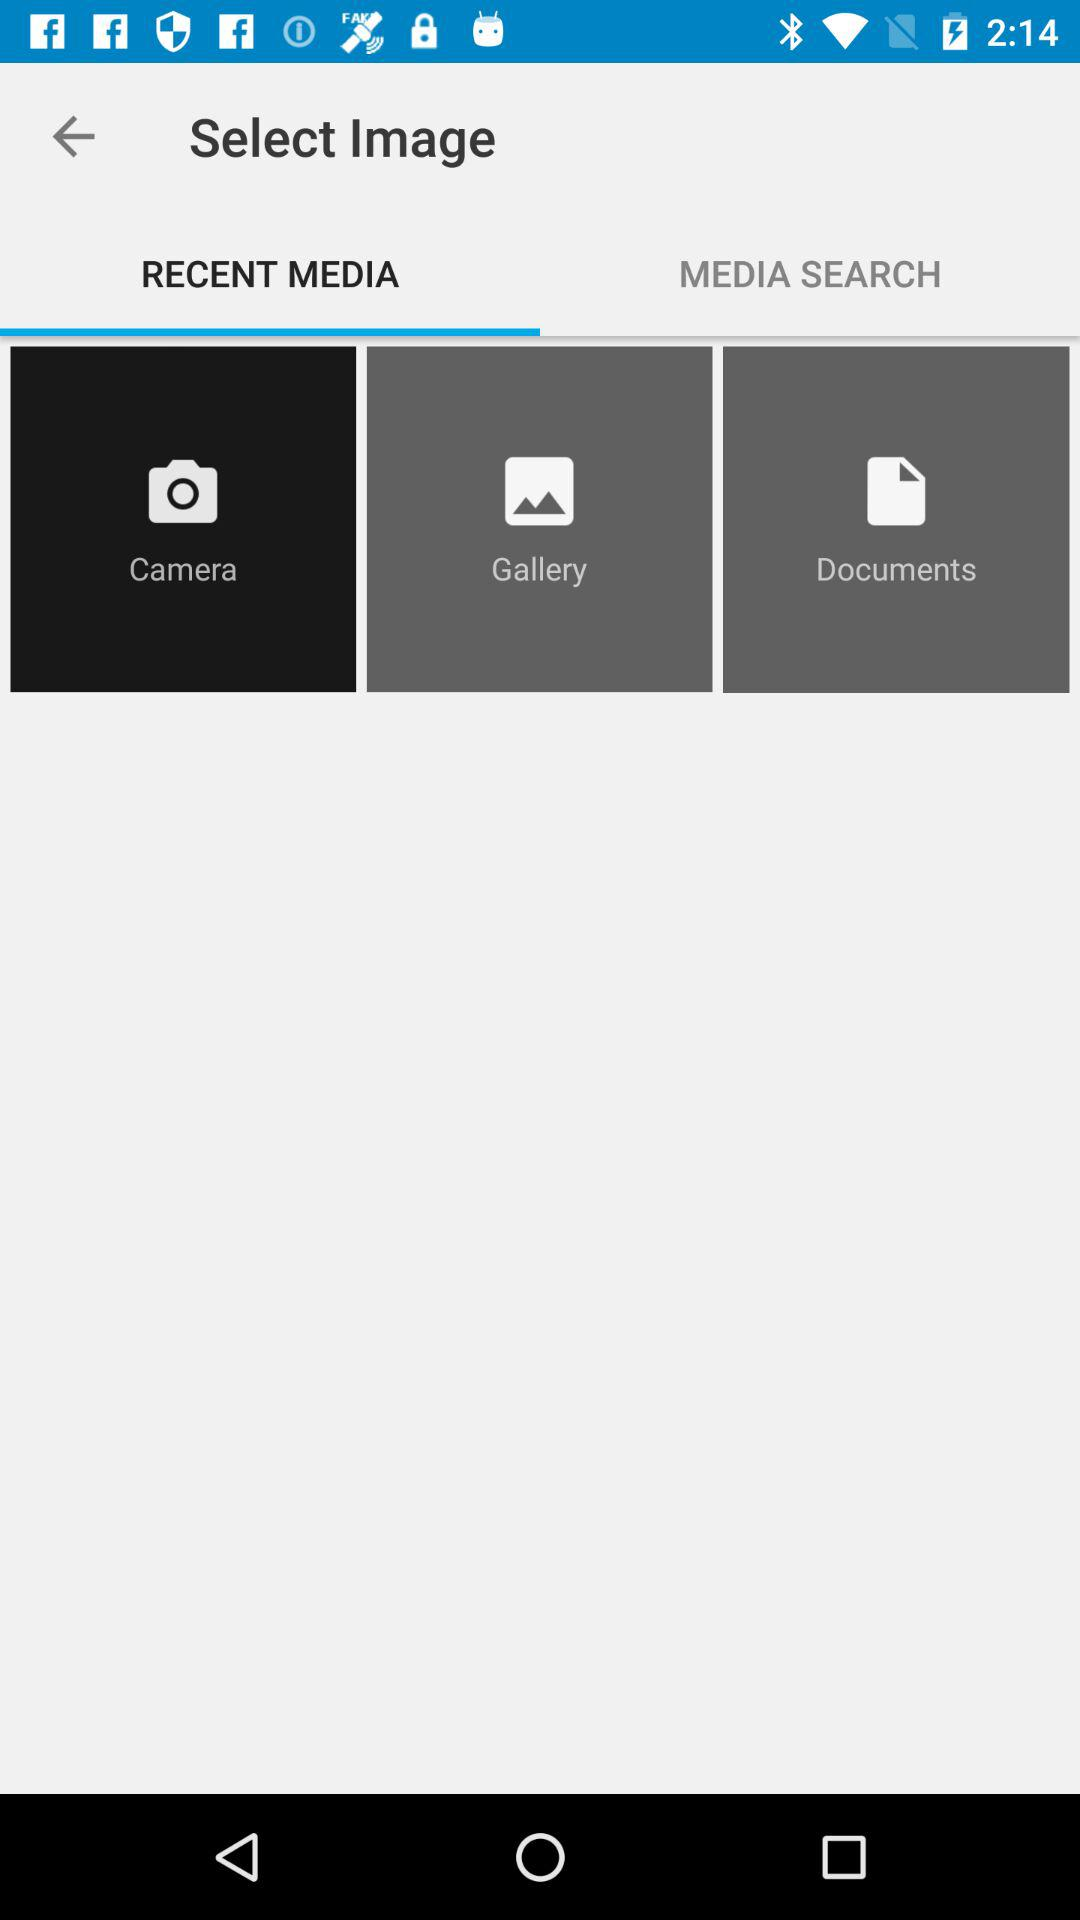Which tab is selected? The selected tab is "RECENT MEDIA". 